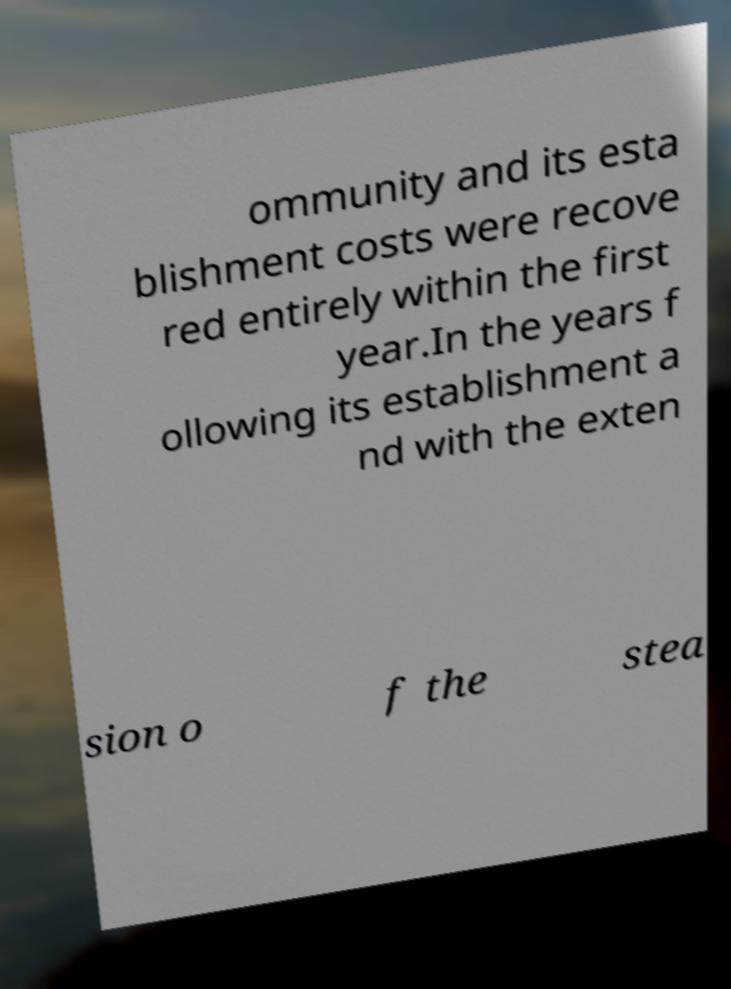I need the written content from this picture converted into text. Can you do that? ommunity and its esta blishment costs were recove red entirely within the first year.In the years f ollowing its establishment a nd with the exten sion o f the stea 